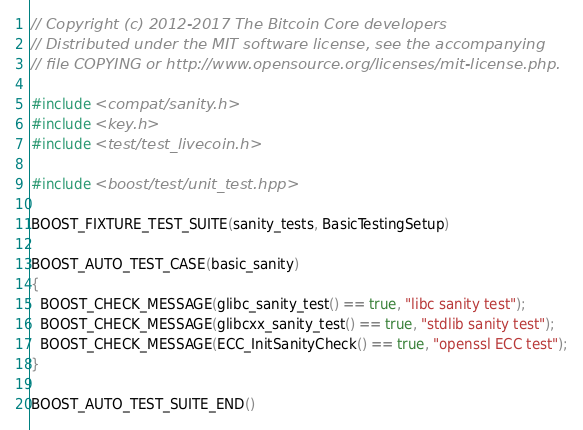Convert code to text. <code><loc_0><loc_0><loc_500><loc_500><_C++_>// Copyright (c) 2012-2017 The Bitcoin Core developers
// Distributed under the MIT software license, see the accompanying
// file COPYING or http://www.opensource.org/licenses/mit-license.php.

#include <compat/sanity.h>
#include <key.h>
#include <test/test_livecoin.h>

#include <boost/test/unit_test.hpp>

BOOST_FIXTURE_TEST_SUITE(sanity_tests, BasicTestingSetup)

BOOST_AUTO_TEST_CASE(basic_sanity)
{
  BOOST_CHECK_MESSAGE(glibc_sanity_test() == true, "libc sanity test");
  BOOST_CHECK_MESSAGE(glibcxx_sanity_test() == true, "stdlib sanity test");
  BOOST_CHECK_MESSAGE(ECC_InitSanityCheck() == true, "openssl ECC test");
}

BOOST_AUTO_TEST_SUITE_END()
</code> 